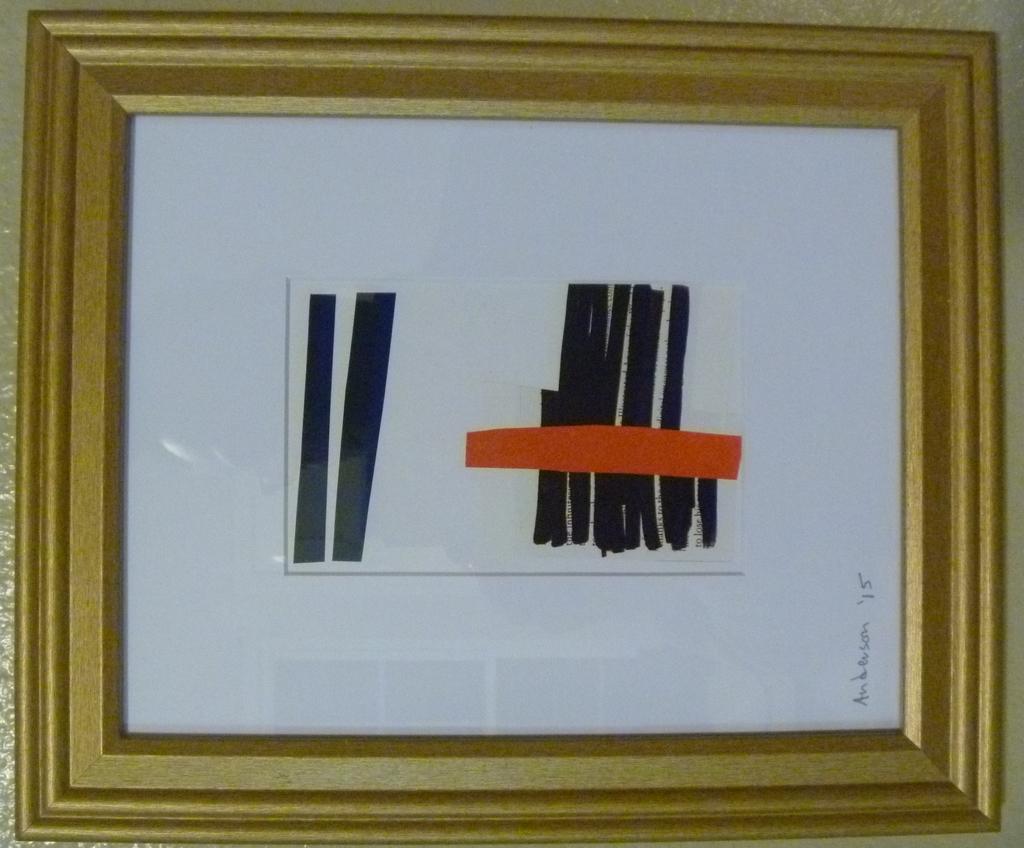How would you summarize this image in a sentence or two? In the picture we can see a photo frame with a white color in that with some black lines and one red line. 